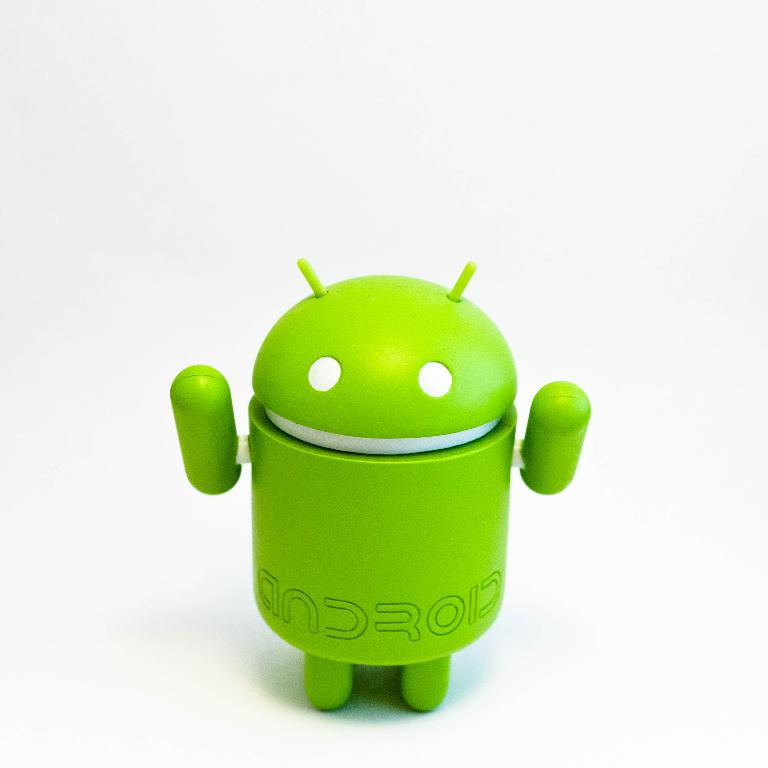What does the color and design of this Android figure represent? The bright green color of the Android figurine typically represents growth and creativity, while its simple and friendly design reflects the approachability and openness of the Android operating system. 